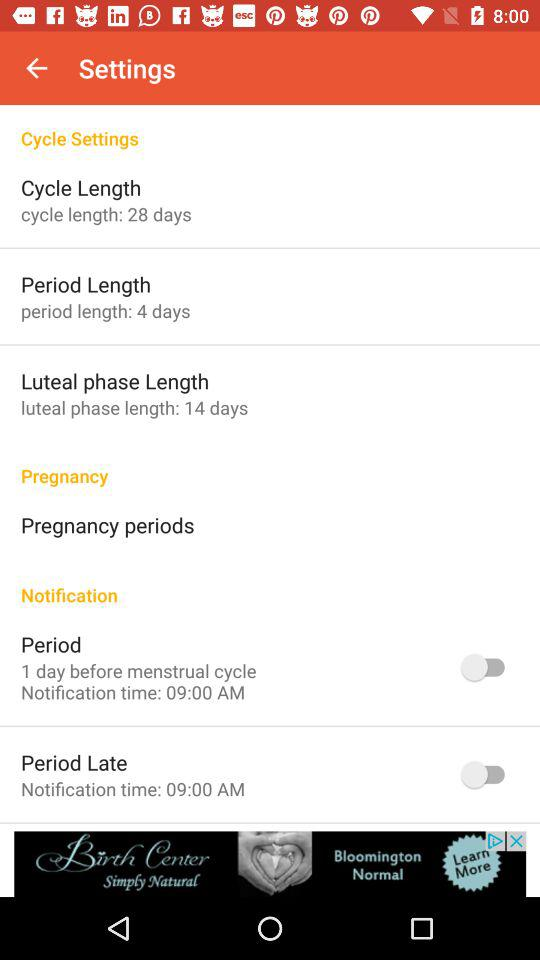What is the period length? The period length is 4 days. 